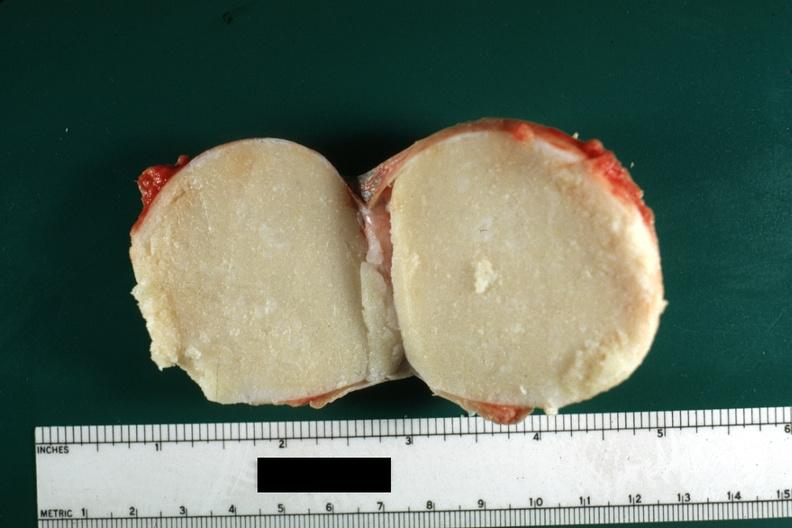what was from the scrotal skin?
Answer the question using a single word or phrase. Typical cheese like yellow content and thin fibrous capsule this lesion 